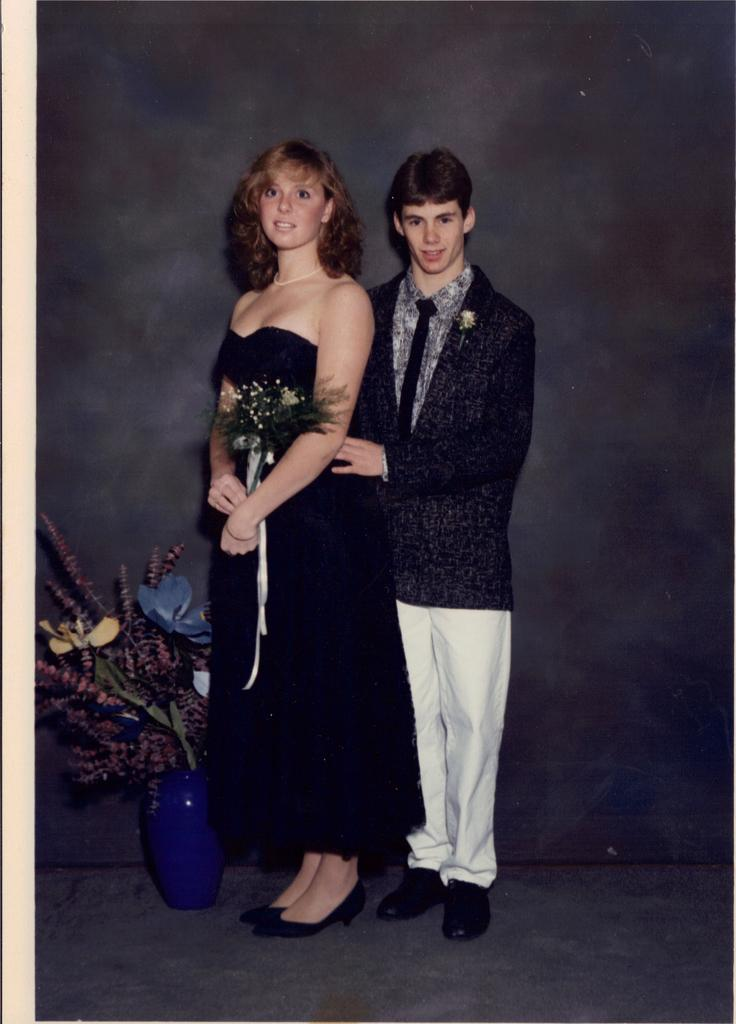How many people are present in the image? There are two people standing in the image. What are the people wearing? The people are wearing black and white dresses. What can be seen to the left of the image? There is a flower vase to the left of the image. What is the color of the background in the image? The background of the image is black. Can you see a train passing over a bridge in the image? No, there is no train or bridge present in the image. What type of cup is being used by one of the people in the image? There is no cup visible in the image; the people are not holding any objects. 